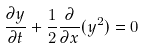<formula> <loc_0><loc_0><loc_500><loc_500>\frac { \partial y } { \partial t } + \frac { 1 } { 2 } \frac { \partial } { \partial x } ( y ^ { 2 } ) = 0</formula> 